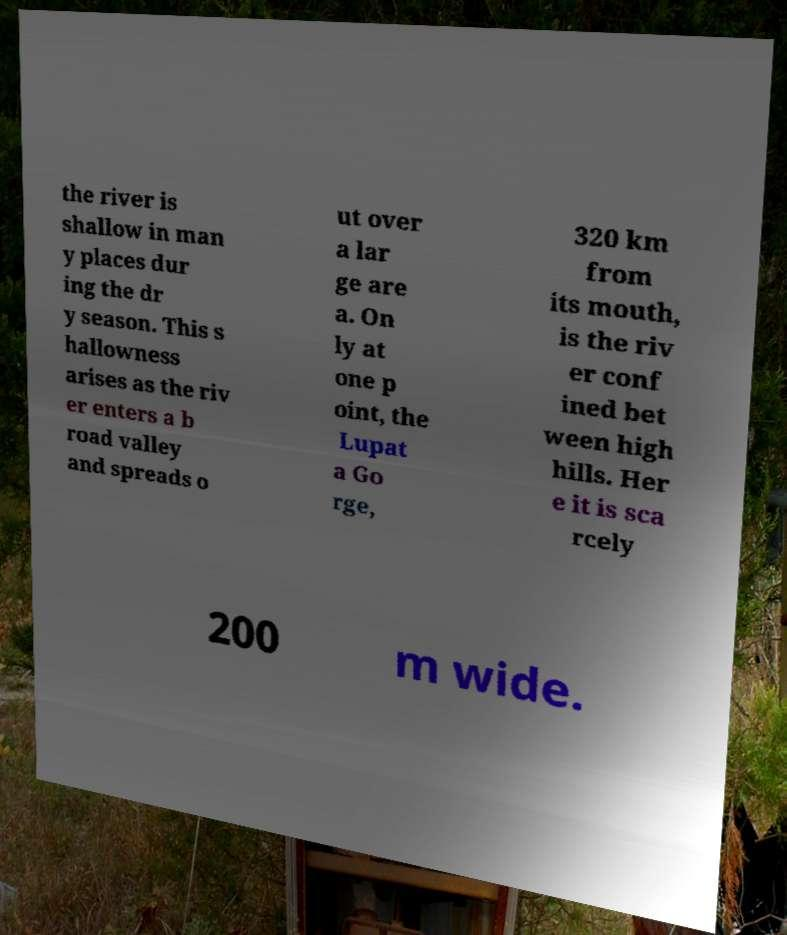Can you read and provide the text displayed in the image?This photo seems to have some interesting text. Can you extract and type it out for me? the river is shallow in man y places dur ing the dr y season. This s hallowness arises as the riv er enters a b road valley and spreads o ut over a lar ge are a. On ly at one p oint, the Lupat a Go rge, 320 km from its mouth, is the riv er conf ined bet ween high hills. Her e it is sca rcely 200 m wide. 